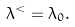<formula> <loc_0><loc_0><loc_500><loc_500>\lambda ^ { < } = \lambda _ { 0 } .</formula> 